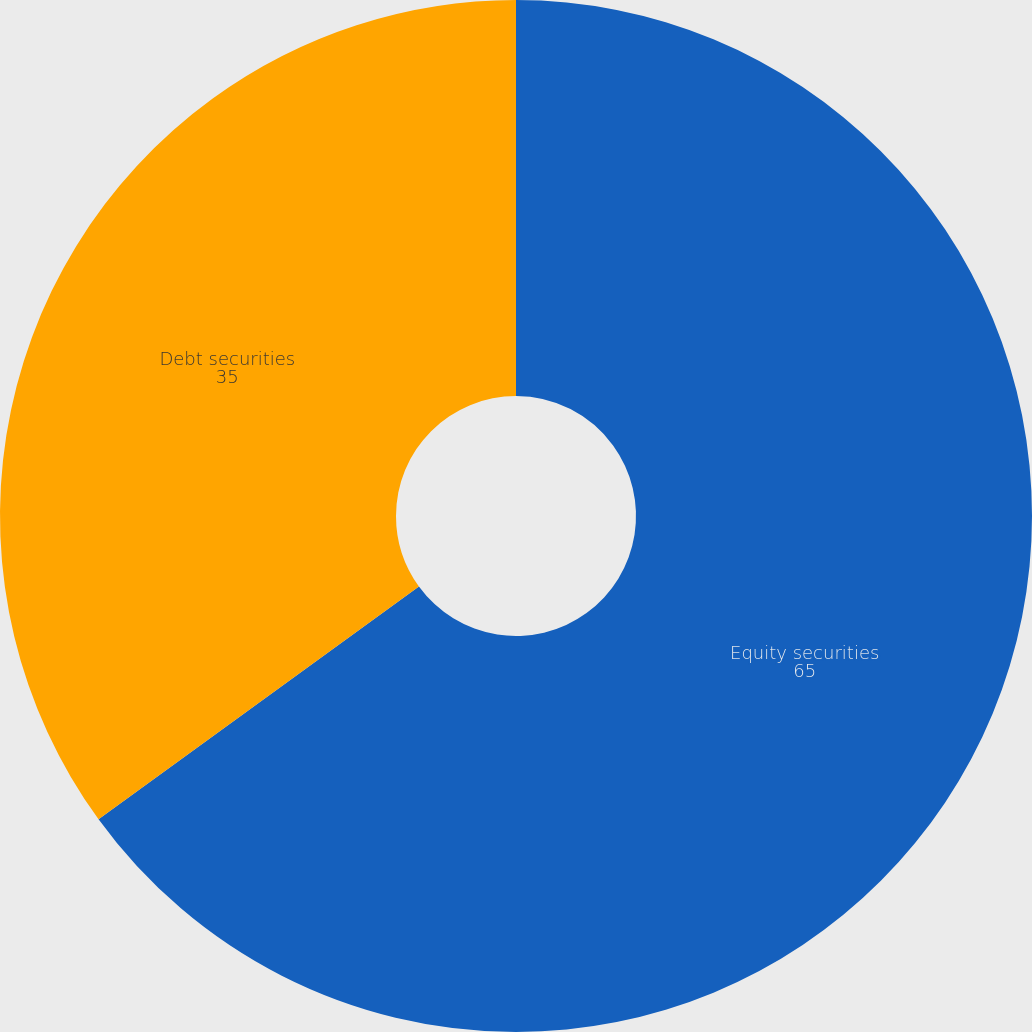Convert chart to OTSL. <chart><loc_0><loc_0><loc_500><loc_500><pie_chart><fcel>Equity securities<fcel>Debt securities<nl><fcel>65.0%<fcel>35.0%<nl></chart> 